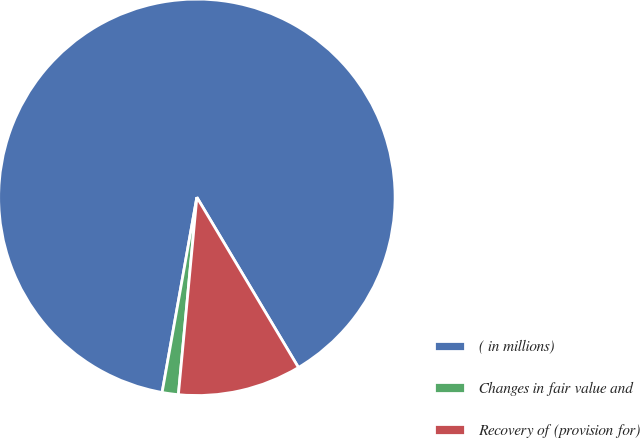Convert chart to OTSL. <chart><loc_0><loc_0><loc_500><loc_500><pie_chart><fcel>( in millions)<fcel>Changes in fair value and<fcel>Recovery of (provision for)<nl><fcel>88.63%<fcel>1.32%<fcel>10.05%<nl></chart> 